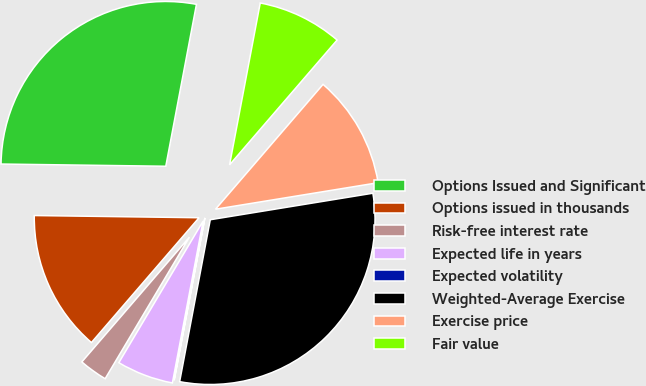<chart> <loc_0><loc_0><loc_500><loc_500><pie_chart><fcel>Options Issued and Significant<fcel>Options issued in thousands<fcel>Risk-free interest rate<fcel>Expected life in years<fcel>Expected volatility<fcel>Weighted-Average Exercise<fcel>Exercise price<fcel>Fair value<nl><fcel>27.77%<fcel>13.89%<fcel>2.78%<fcel>5.56%<fcel>0.01%<fcel>30.55%<fcel>11.11%<fcel>8.34%<nl></chart> 